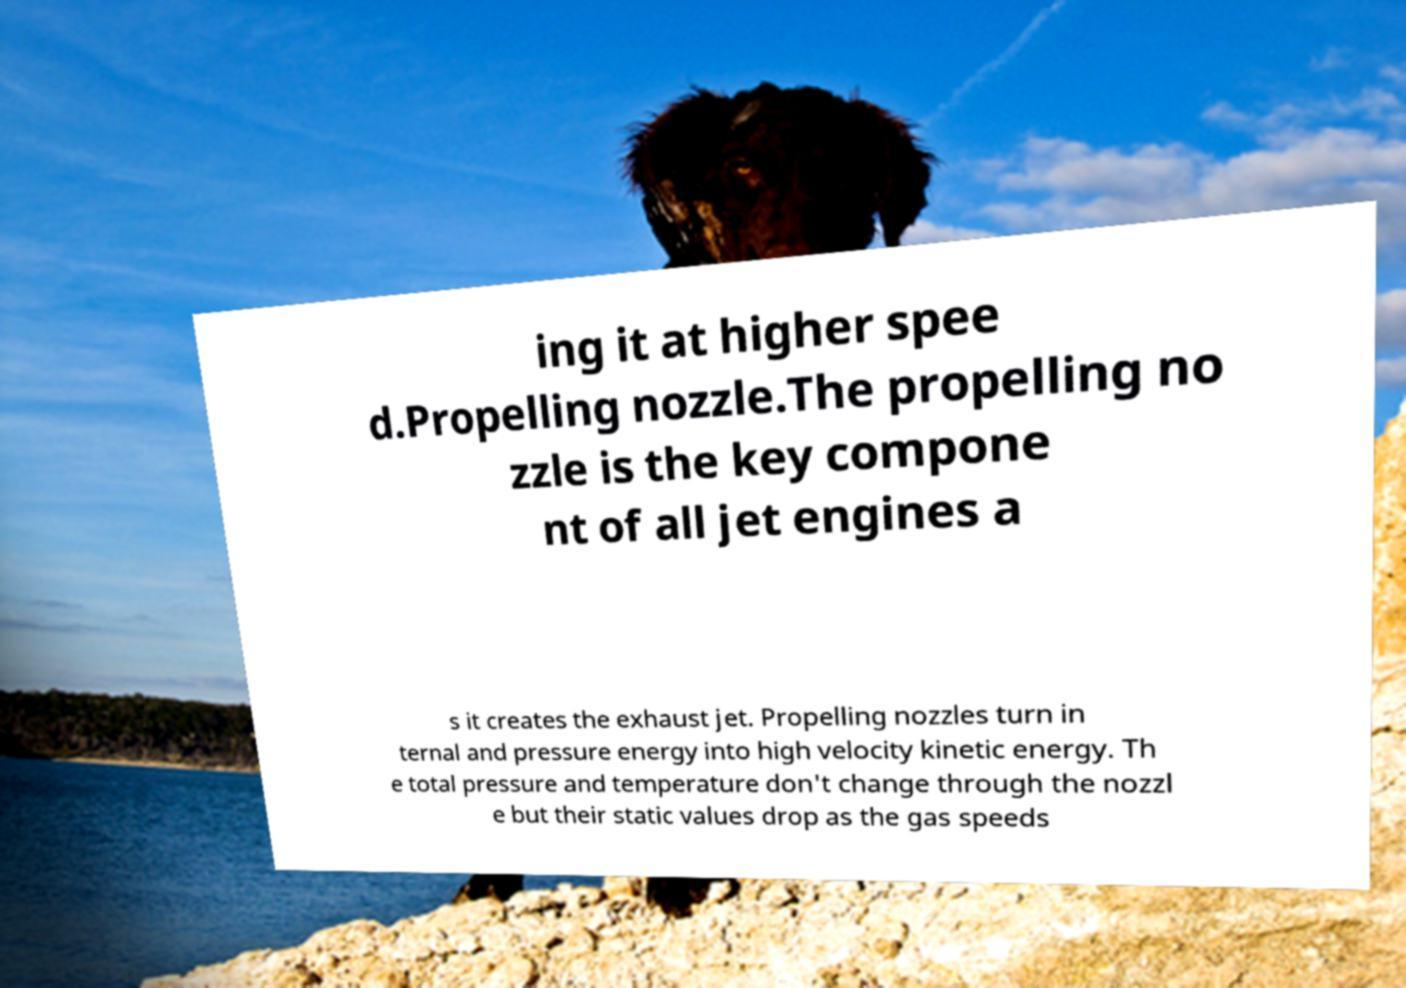For documentation purposes, I need the text within this image transcribed. Could you provide that? ing it at higher spee d.Propelling nozzle.The propelling no zzle is the key compone nt of all jet engines a s it creates the exhaust jet. Propelling nozzles turn in ternal and pressure energy into high velocity kinetic energy. Th e total pressure and temperature don't change through the nozzl e but their static values drop as the gas speeds 